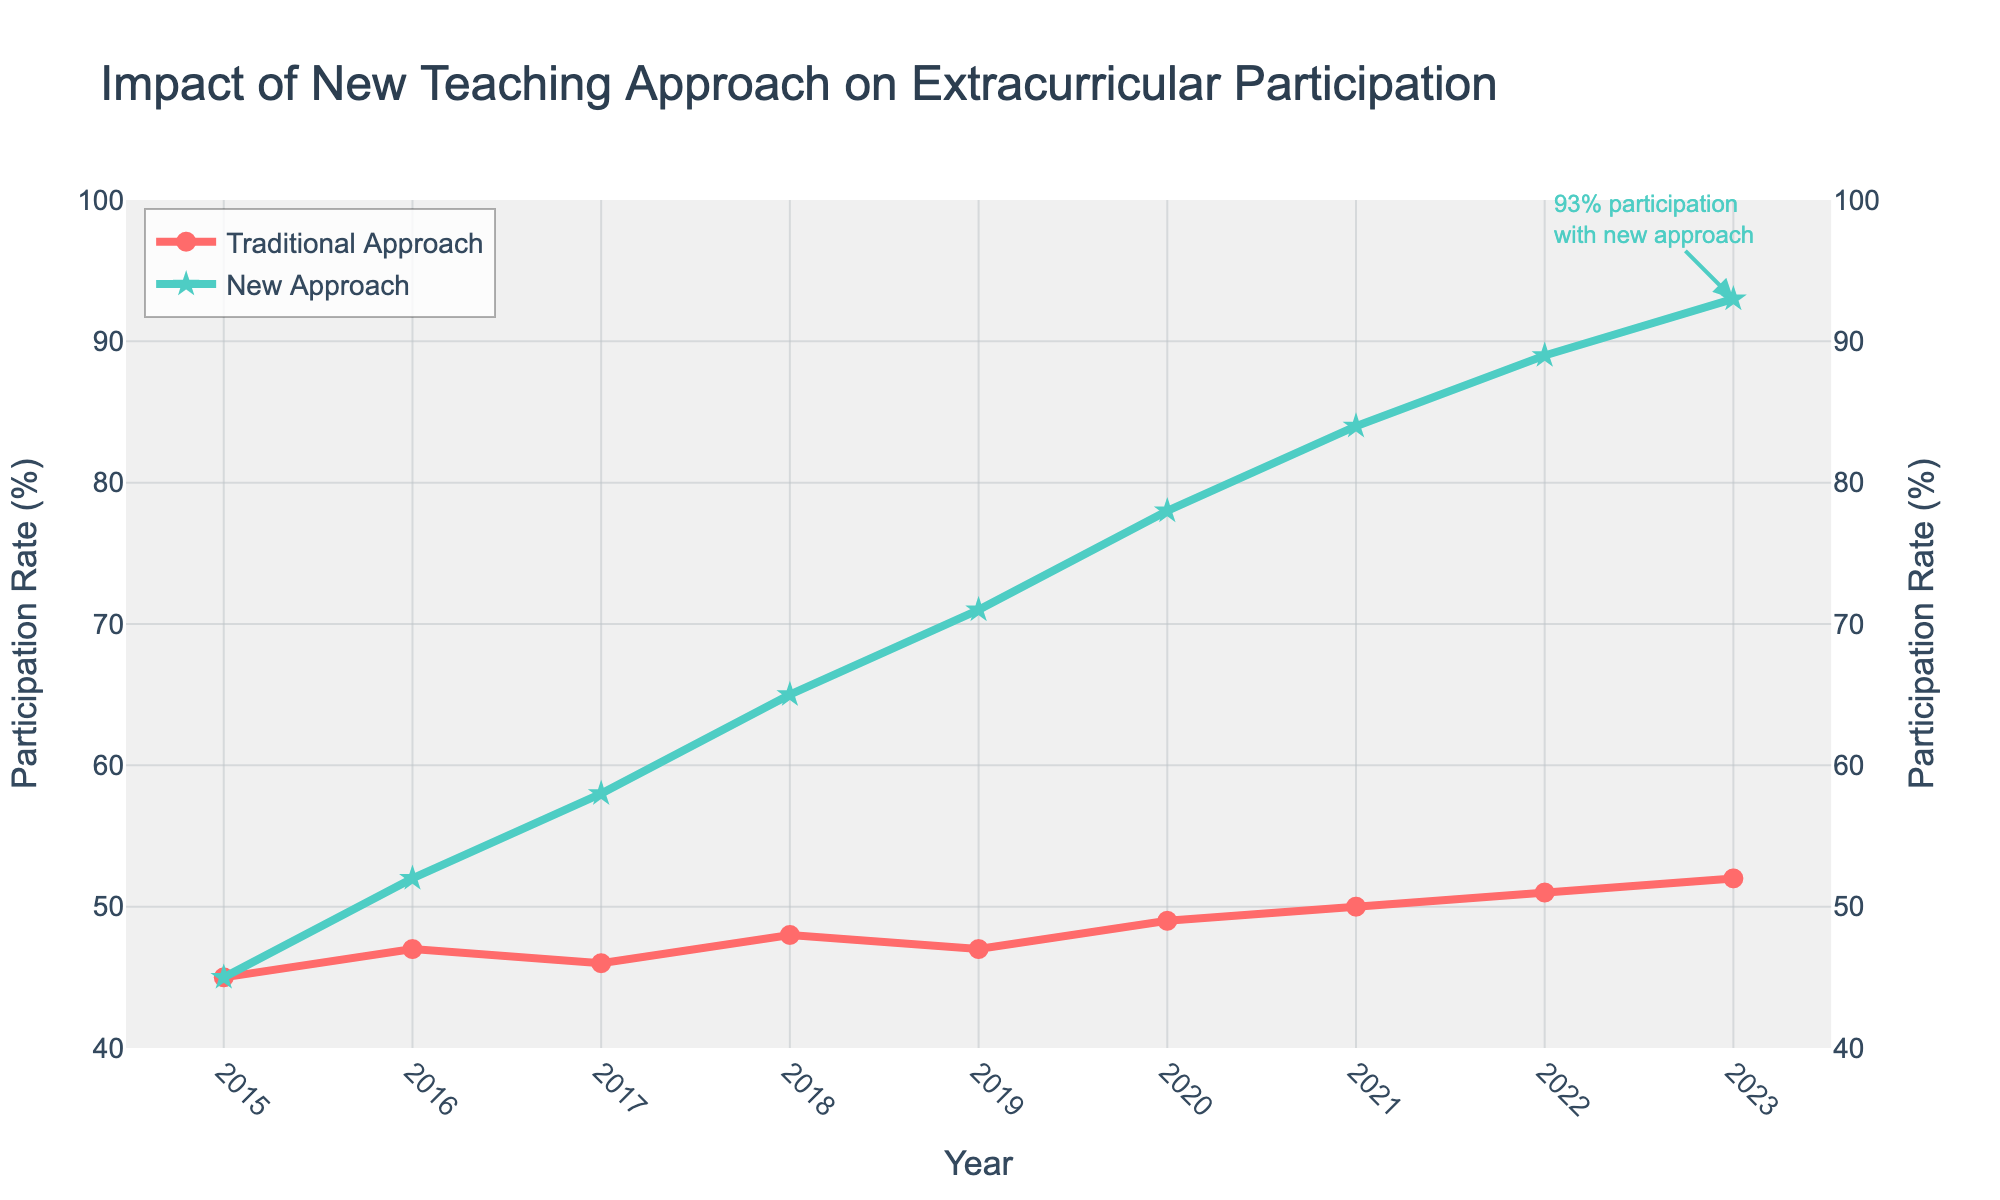What's the participation rate in extracurricular activities in 2023 for both approaches? For the Traditional Approach, the value is directly under the 2023 mark, which is 52%. For the New Approach, it is shown as 93%.
Answer: Traditional: 52%, New: 93% How much did the participation rate increase from 2015 to 2023 under the New Approach? Subtract the 2015 participation rate for the New Approach (45%) from the 2023 participation rate (93%). 93% - 45% = 48%.
Answer: 48% Which year showed the largest difference in participation rates between the Traditional and New Approaches? Look at the differences between the two rates for each year from 2016 to 2023. The largest difference is in 2023 where Traditional Approach is 52% and New Approach is 93%, a difference of 41%.
Answer: 2023 Compare the trends of the Traditional and New Approaches from 2015 to 2023. What do you observe? The participation rate of the Traditional Approach increases gradually and slightly, moving from 45% to 52%. The New Approach, however, increases significantly and consistently from 45% to 93%. This indicates a much steeper upward trend for the New Approach.
Answer: Traditional: gradual, New: steep increase By how much did the participation rates increase on average per year for the New Approach from 2015 to 2023? Calculate the total increase for the New Approach: 93% - 45% = 48%. Then, divide this by the number of years between 2015 and 2023 (which is 8 years). 48% / 8 = 6%.
Answer: 6% What is the difference in participation rates between the Traditional and New Approaches in 2020? Subtract the 2020 participation rate for the Traditional Approach (49%) from the rate for the New Approach (78%). 78% - 49% = 29%.
Answer: 29% During which years did the New Approach participation rate exceed 70%? Check the New Approach participation rates year by year. The rates exceed 70% in the years 2019 (71%), 2020 (78%), 2021 (84%), 2022 (89%), and 2023 (93%).
Answer: 2019-2023 How does the annotation in the figure highlight the success of the New Approach? The annotation shows a specific data point for the year 2023 where the New Approach reached a high participation rate of 93%, using both visual cues (arrow, highlighted text) and text to emphasize this success.
Answer: Highlights 93% in 2023 